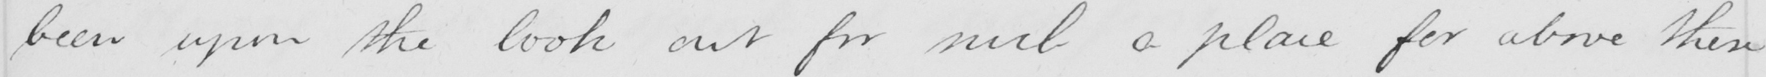What is written in this line of handwriting? been upon the look out for such a place for above these 